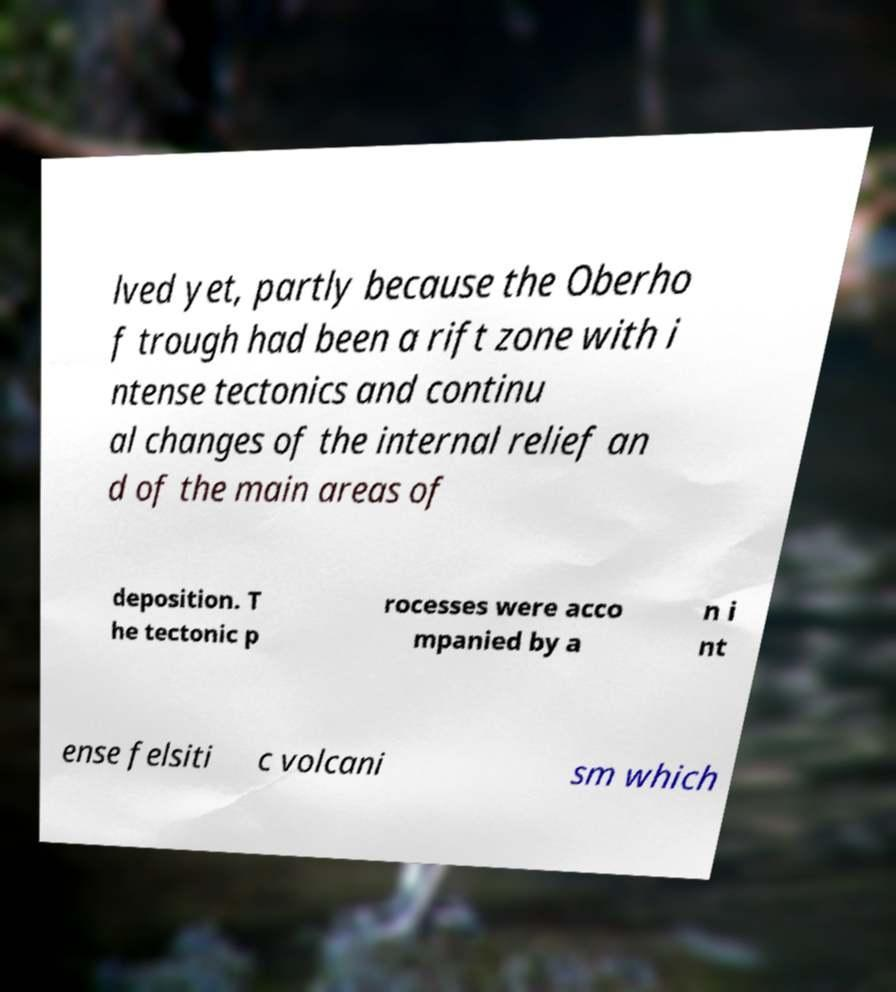Could you extract and type out the text from this image? lved yet, partly because the Oberho f trough had been a rift zone with i ntense tectonics and continu al changes of the internal relief an d of the main areas of deposition. T he tectonic p rocesses were acco mpanied by a n i nt ense felsiti c volcani sm which 